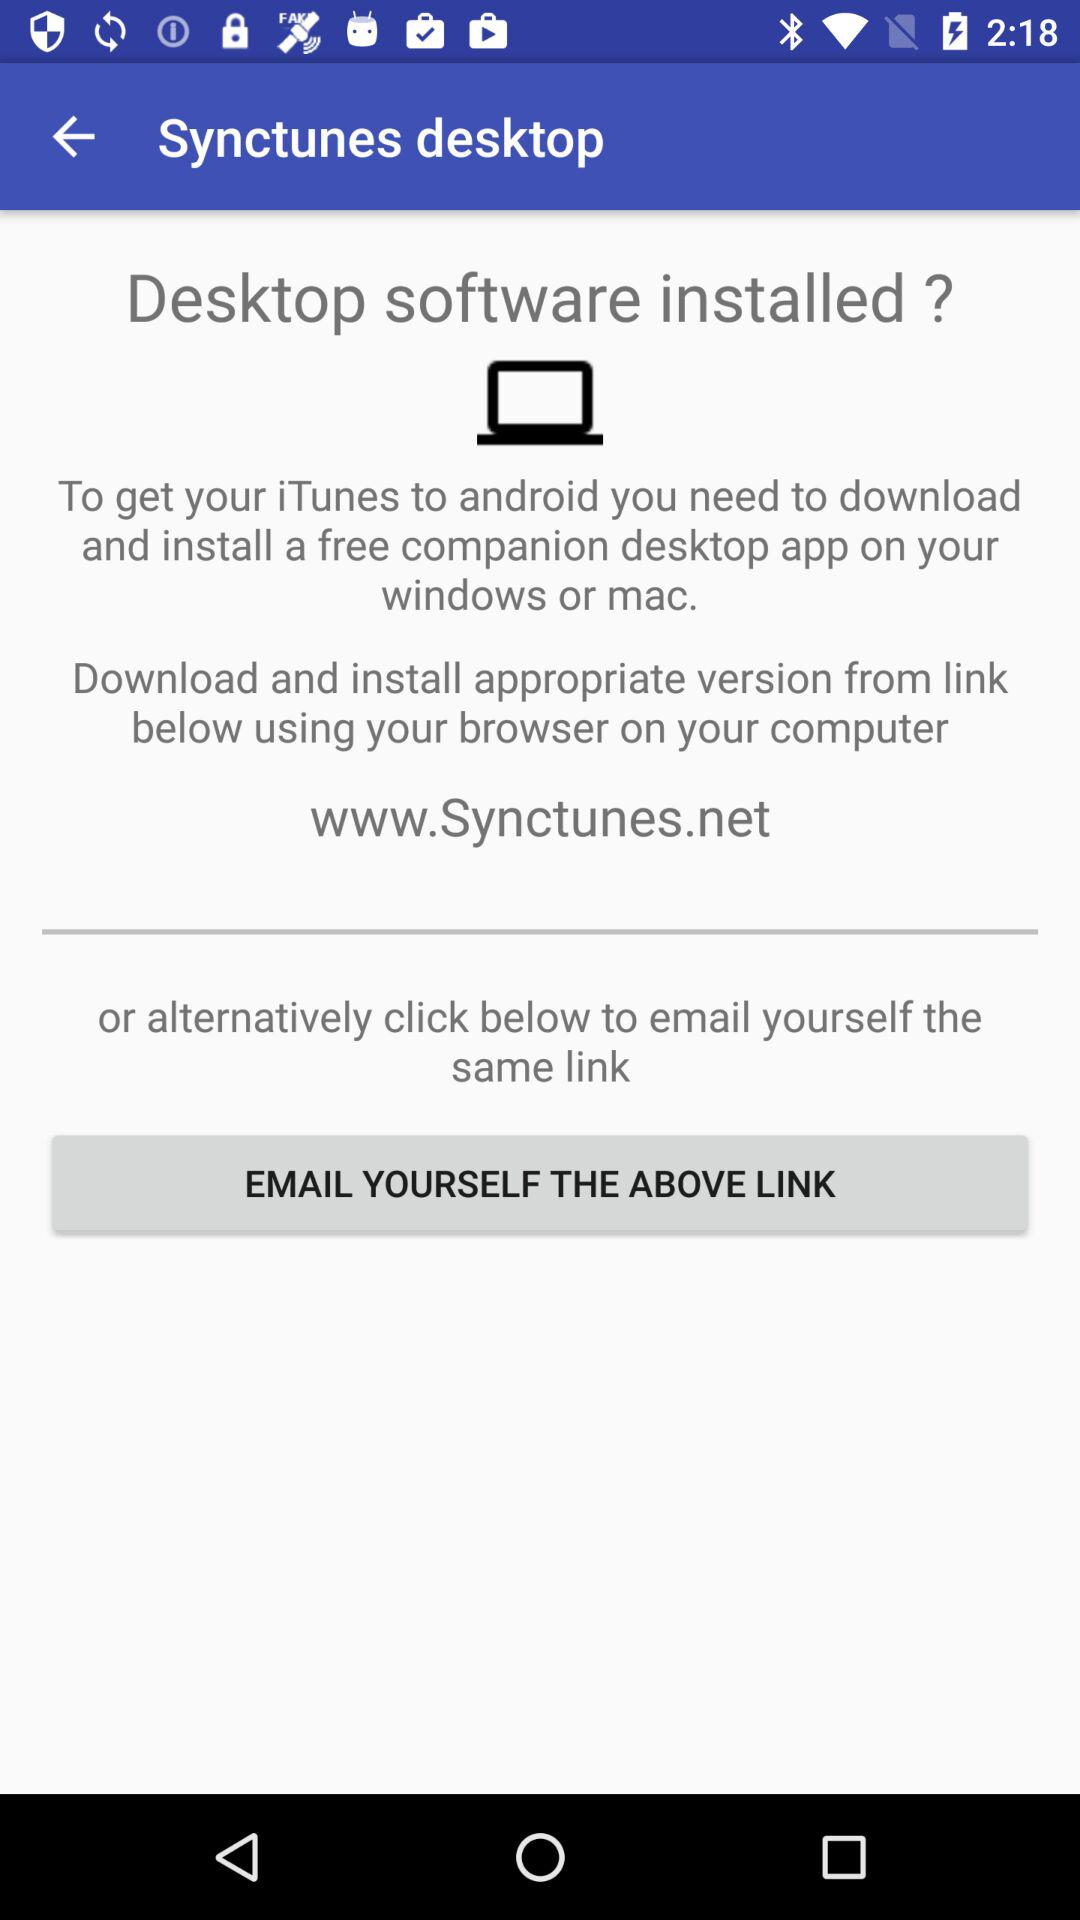How many ways are there to get the desktop software?
Answer the question using a single word or phrase. 2 